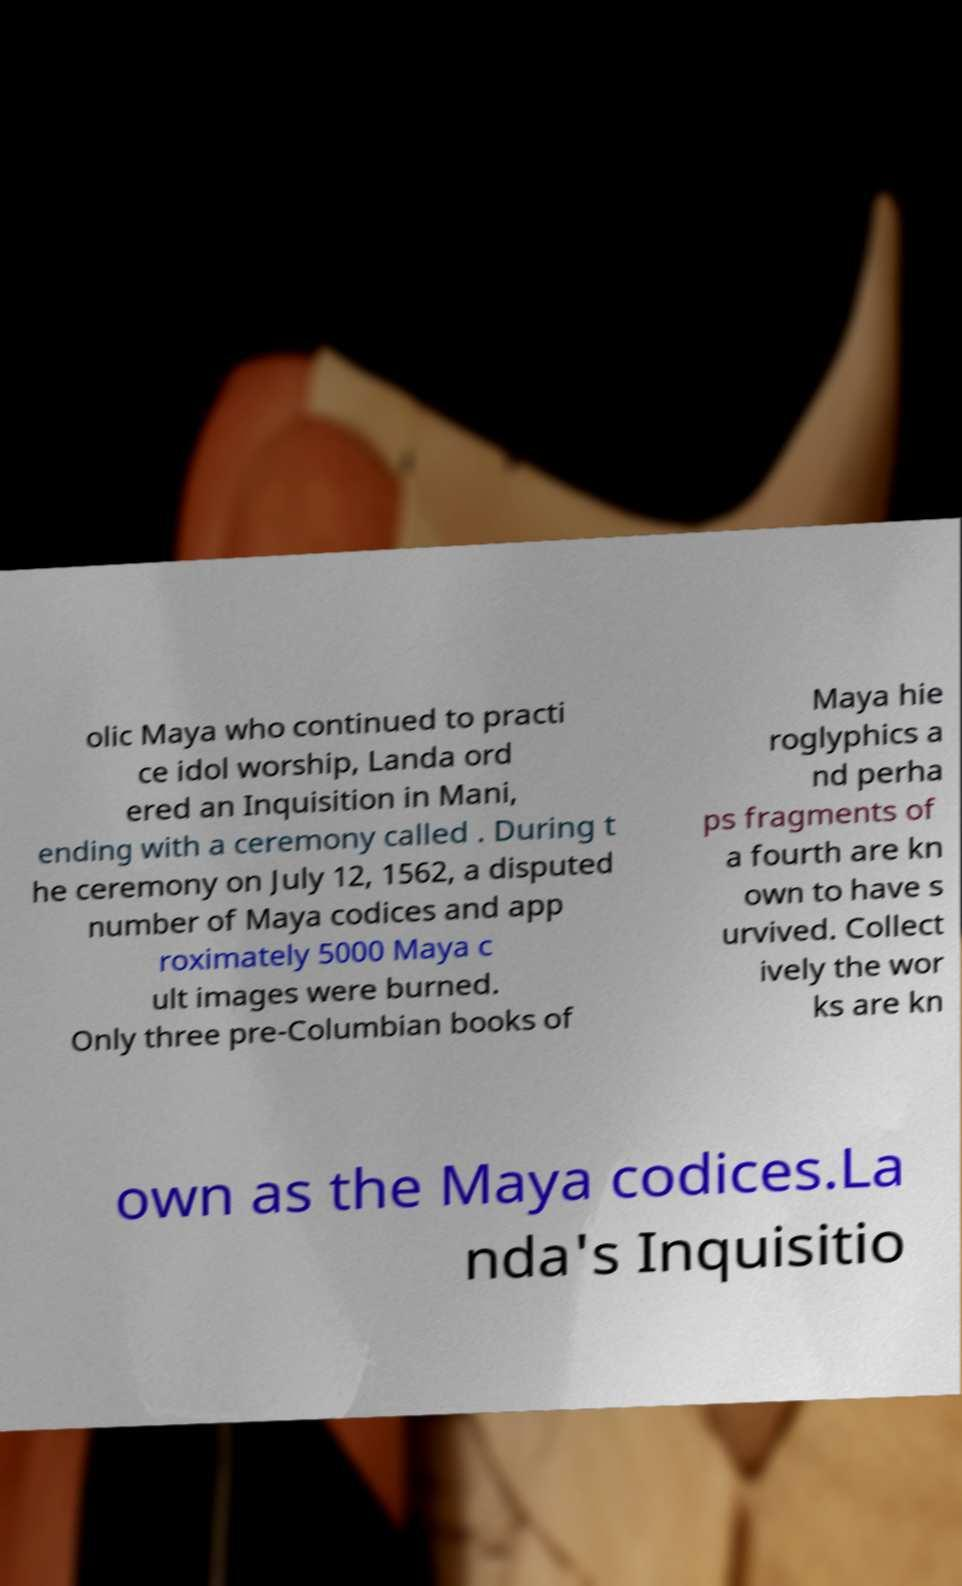Please read and relay the text visible in this image. What does it say? olic Maya who continued to practi ce idol worship, Landa ord ered an Inquisition in Mani, ending with a ceremony called . During t he ceremony on July 12, 1562, a disputed number of Maya codices and app roximately 5000 Maya c ult images were burned. Only three pre-Columbian books of Maya hie roglyphics a nd perha ps fragments of a fourth are kn own to have s urvived. Collect ively the wor ks are kn own as the Maya codices.La nda's Inquisitio 